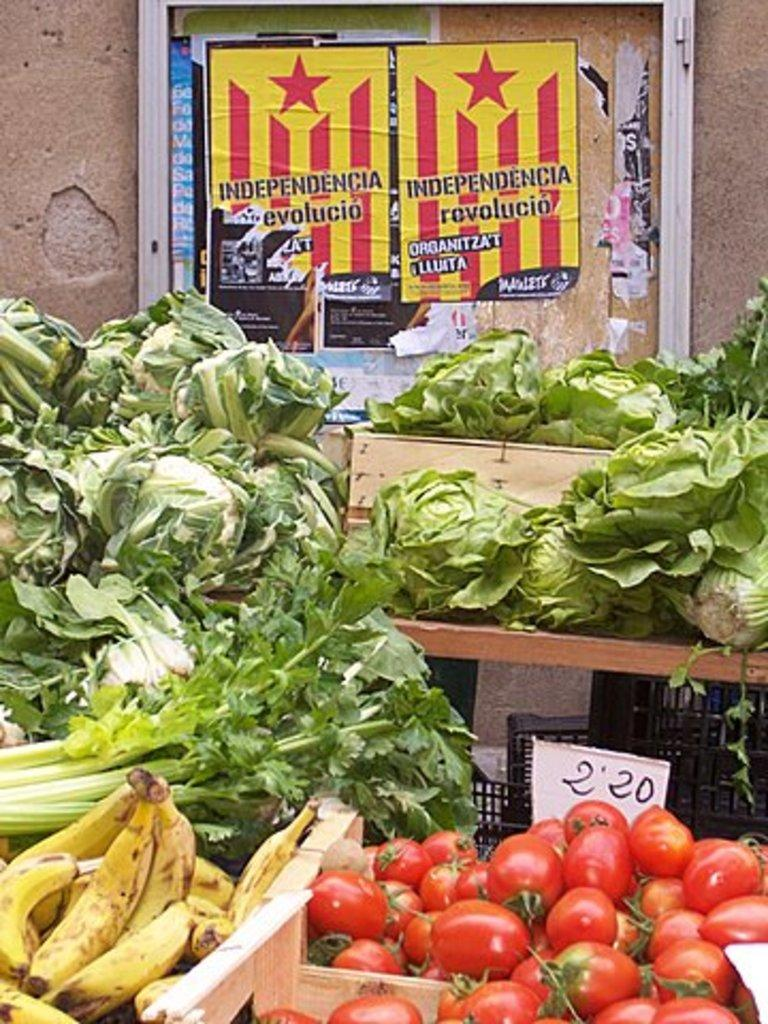What type of food items can be seen in the image? There are vegetables in the image. How are the vegetables stored or displayed in the image? The vegetables are kept in different containers. What can be seen in the background of the image? There is a poster behind the vegetables. What type of vein is visible in the image? There is no vein visible in the image; it features vegetables in containers with a poster in the background. 